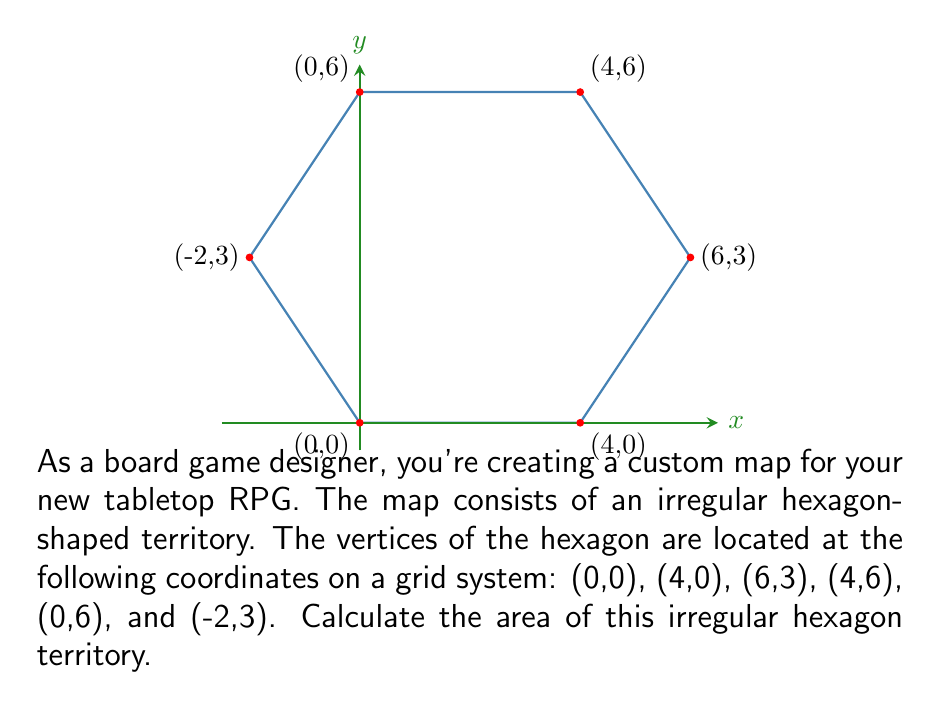Can you solve this math problem? To calculate the area of this irregular hexagon, we can use the Shoelace formula (also known as the surveyor's formula). This formula calculates the area of a polygon given the coordinates of its vertices.

The Shoelace formula is:

$$ A = \frac{1}{2}\left|\sum_{i=1}^{n} (x_i y_{i+1} - x_{i+1} y_i)\right| $$

Where $(x_i, y_i)$ are the coordinates of the $i$-th vertex, and $(x_{n+1}, y_{n+1}) = (x_1, y_1)$ (i.e., we loop back to the first vertex).

Let's apply this formula to our hexagon:

1) List the coordinates in order:
   $(0,0)$, $(4,0)$, $(6,3)$, $(4,6)$, $(0,6)$, $(-2,3)$, $(0,0)$

2) Calculate each term in the sum:
   $0 \cdot 0 - 4 \cdot 0 = 0$
   $4 \cdot 3 - 6 \cdot 0 = 12$
   $6 \cdot 6 - 4 \cdot 3 = 24$
   $4 \cdot 6 - 0 \cdot 6 = 24$
   $0 \cdot 3 - (-2) \cdot 6 = 12$
   $(-2) \cdot 0 - 0 \cdot 3 = 0$

3) Sum these terms:
   $0 + 12 + 24 + 24 + 12 + 0 = 72$

4) Take the absolute value and divide by 2:
   $A = \frac{1}{2}|72| = 36$

Therefore, the area of the irregular hexagon is 36 square units.
Answer: 36 square units 